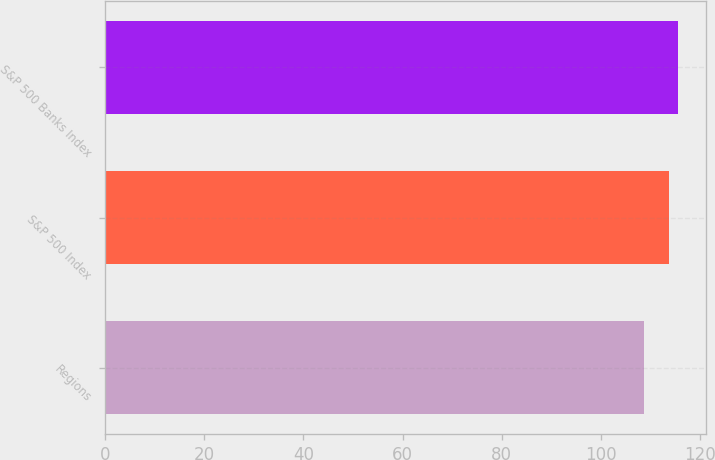Convert chart. <chart><loc_0><loc_0><loc_500><loc_500><bar_chart><fcel>Regions<fcel>S&P 500 Index<fcel>S&P 500 Banks Index<nl><fcel>108.63<fcel>113.68<fcel>115.51<nl></chart> 